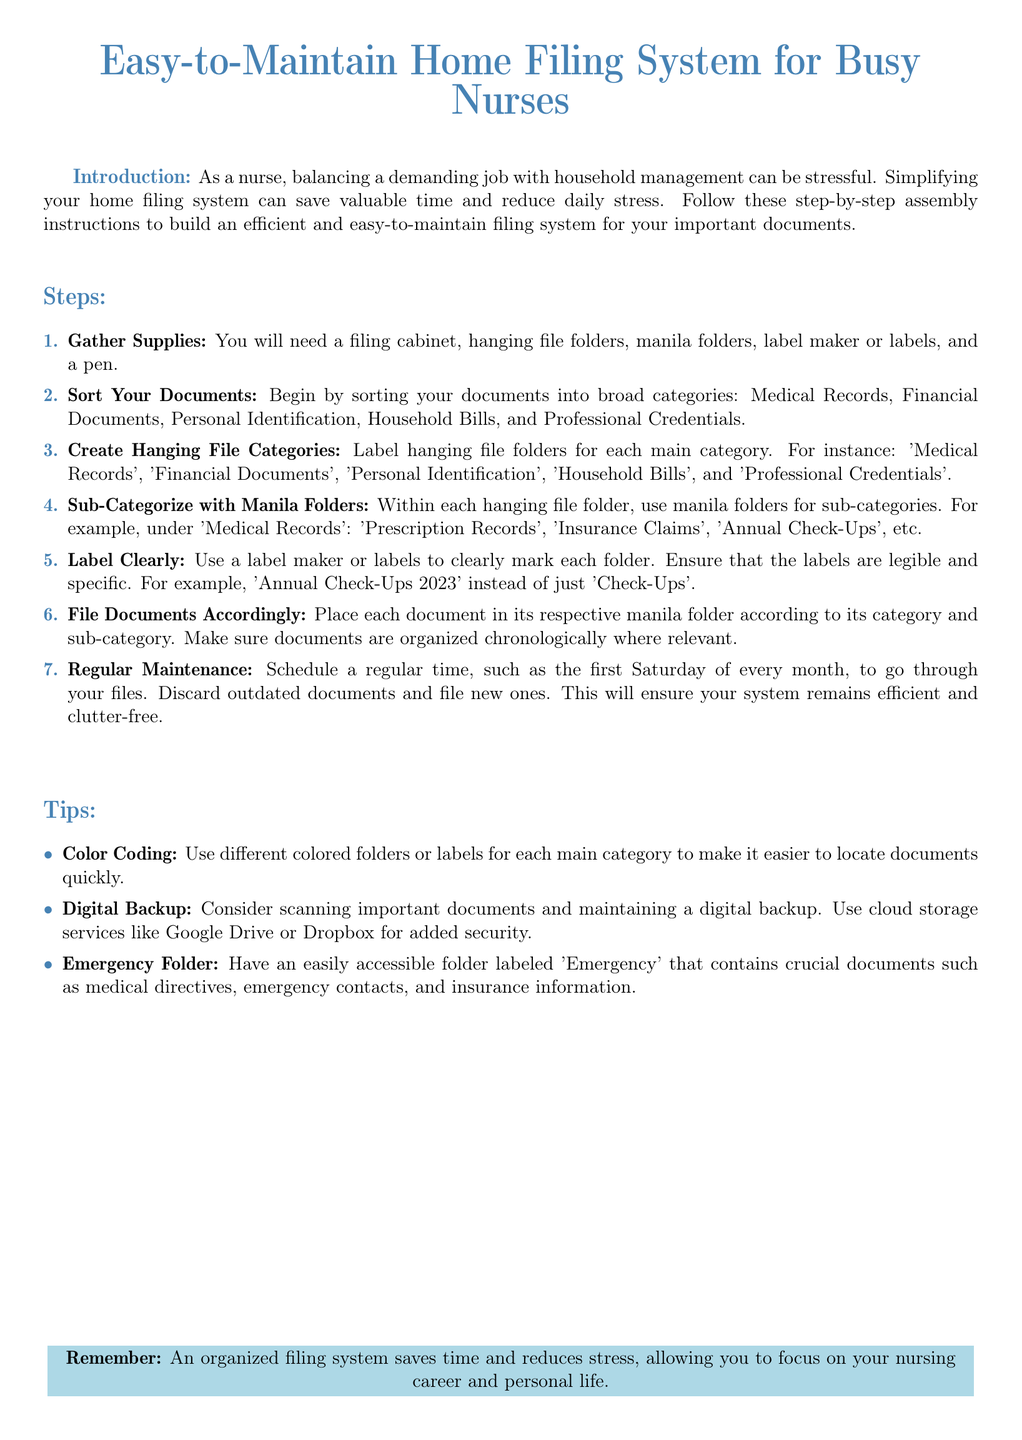What is the main purpose of the document? The document aims to simplify the home filing system for busy nurses, making it efficient and easy to maintain.
Answer: Simplify home filing system How many main categories are suggested for sorting documents? The document lists five broad categories for sorting documents.
Answer: Five What is the first step in building the filing system? The first step involves gathering necessary supplies such as folders and a filing cabinet.
Answer: Gather Supplies Which category is listed under sub-categories for 'Medical Records'? The sub-categories under 'Medical Records' include items like 'Prescription Records' and 'Insurance Claims'.
Answer: Prescription Records What color is suggested for labeling folders? The document recommends using different colored folders or labels for easier document location.
Answer: Colored folders How often should regular maintenance be scheduled? The document suggests scheduling regular maintenance every month.
Answer: Monthly What type of folder should be accessible for emergencies? The document emphasizes having an easily accessible folder labeled 'Emergency'.
Answer: Emergency What is a suggested method for backing up important documents? A digital backup using cloud storage services is recommended for important documents.
Answer: Cloud storage services What should be ensured while labeling folders? The document advises that labels should be legible and specific for clarity.
Answer: Legible and specific What should be done with outdated documents during maintenance? The document instructs to discard outdated documents during the regular maintenance.
Answer: Discard 